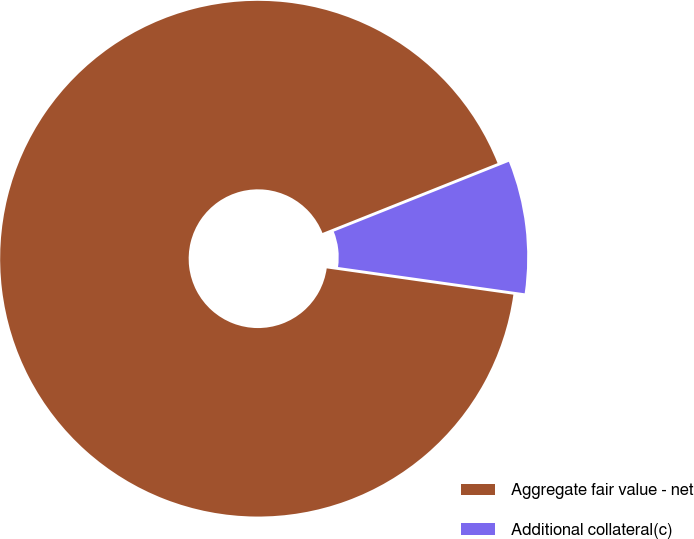Convert chart. <chart><loc_0><loc_0><loc_500><loc_500><pie_chart><fcel>Aggregate fair value - net<fcel>Additional collateral(c)<nl><fcel>91.73%<fcel>8.27%<nl></chart> 